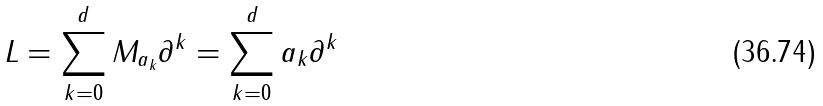<formula> <loc_0><loc_0><loc_500><loc_500>L = \sum _ { k = 0 } ^ { d } M _ { a _ { k } } \partial ^ { k } = \sum _ { k = 0 } ^ { d } a _ { k } \partial ^ { k }</formula> 